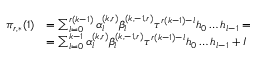<formula> <loc_0><loc_0><loc_500><loc_500>\begin{array} { r l } { \pi _ { r , * } ( 1 ) } & { = \sum _ { l = 0 } ^ { r ( k - 1 ) } \alpha _ { l } ^ { ( k , r ) } \beta _ { l } ^ { ( k , - 1 , r ) } \tau ^ { r ( k - 1 ) - l } h _ { 0 } \dots h _ { l - 1 } = } \\ & { = \sum _ { l = 0 } ^ { k - 1 } \alpha _ { l } ^ { ( k , r ) } \beta _ { l } ^ { ( k , - 1 , r ) } \tau ^ { r ( k - 1 ) - l } h _ { 0 } \dots h _ { l - 1 } + I } \end{array}</formula> 